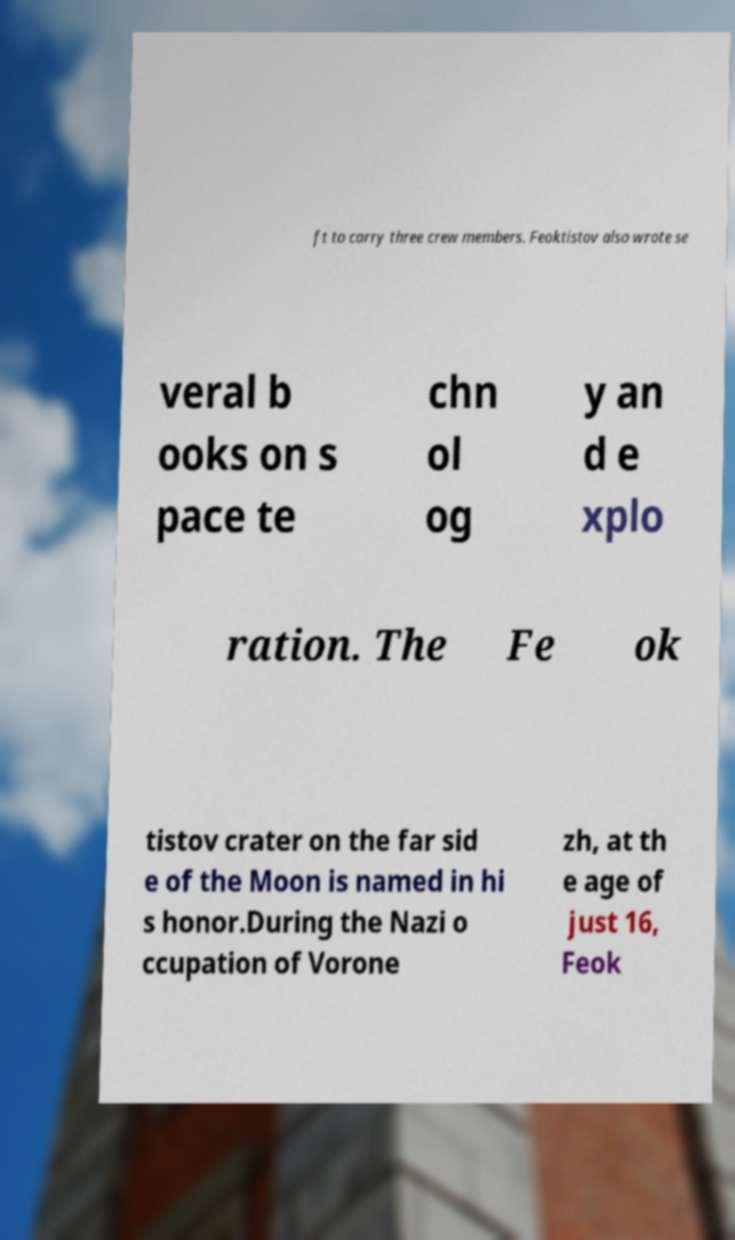I need the written content from this picture converted into text. Can you do that? ft to carry three crew members. Feoktistov also wrote se veral b ooks on s pace te chn ol og y an d e xplo ration. The Fe ok tistov crater on the far sid e of the Moon is named in hi s honor.During the Nazi o ccupation of Vorone zh, at th e age of just 16, Feok 